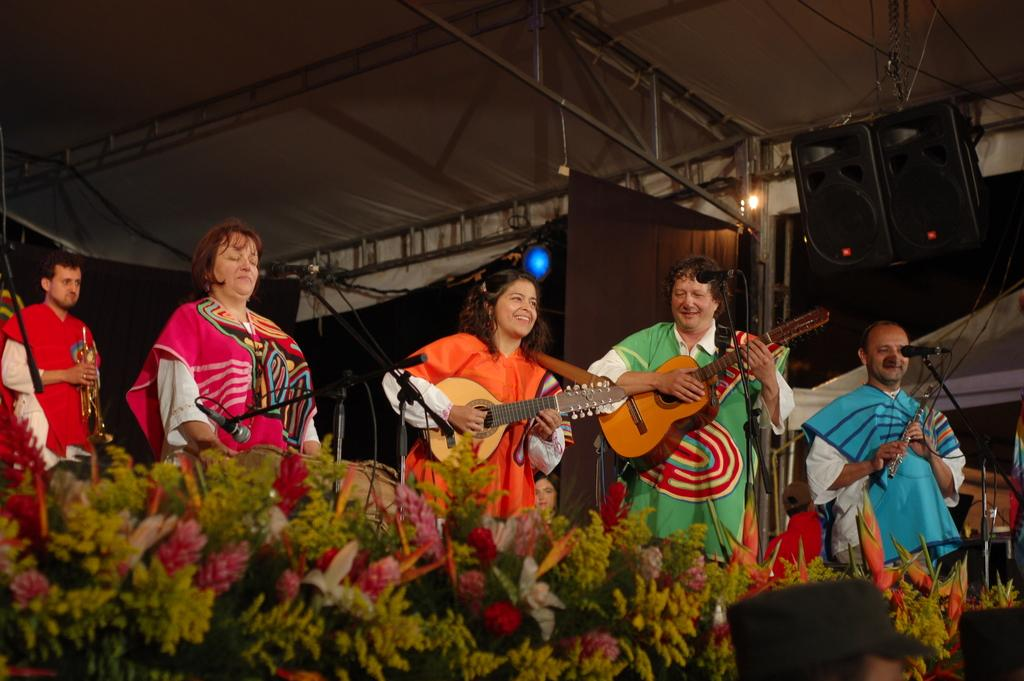What are the persons in the image doing? The persons in the image are playing guitar. What object is present for amplifying their voices? There is a microphone (mike) in the image. What type of decorative plants can be seen in the image? There are flowers in the image. What can be seen in the background of the image? There is a light in the background of the image. What structure is visible in the image? There is a roof visible in the image. What type of sand can be seen in the image? There is no sand present in the image. What color is the rock in the image? There is no rock present in the image. 